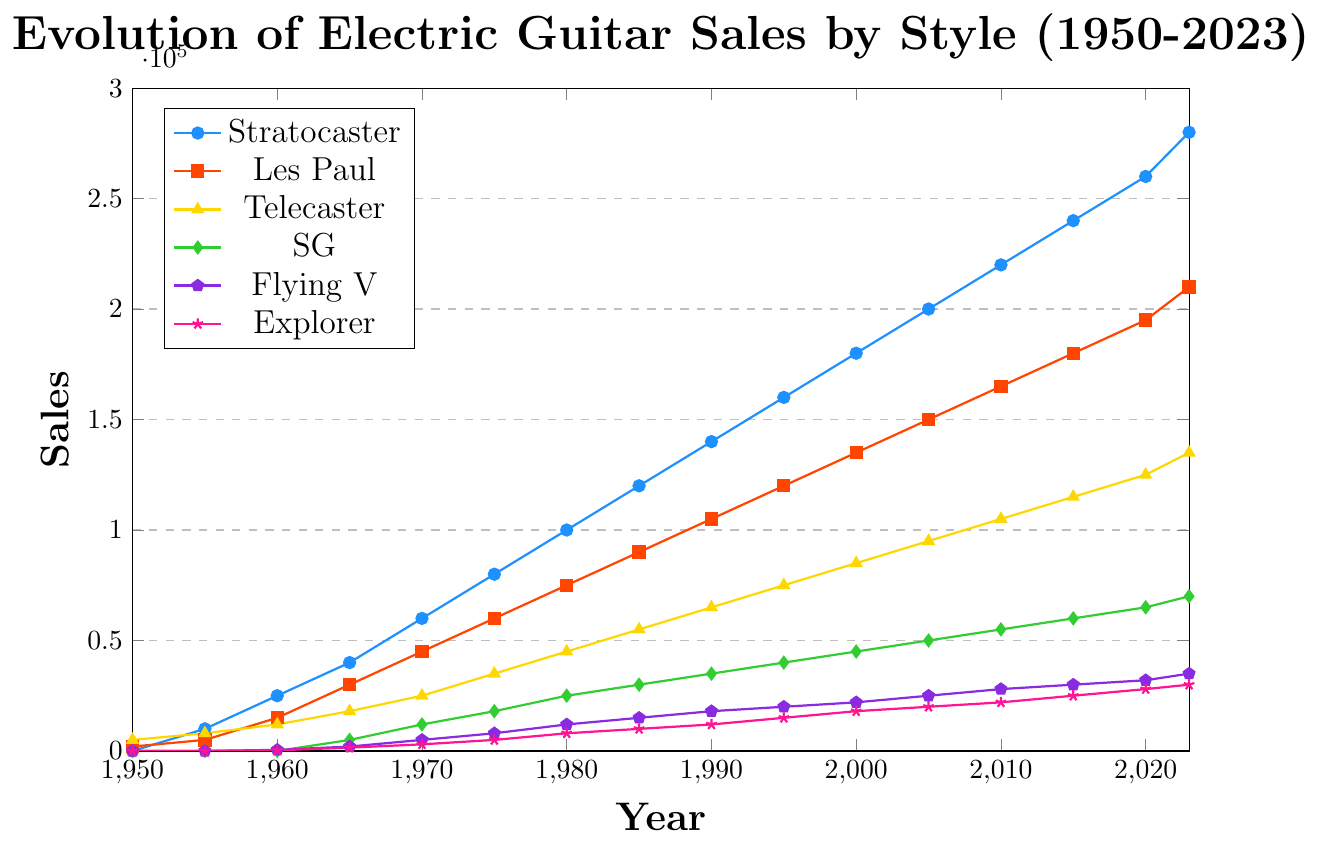Which electric guitar style shows the highest sales in 2023? To find the guitar style with the highest sales in 2023, look at the rightmost data points on the chart. The Stratocaster reaches the highest position on the y-axis, indicating the highest sales.
Answer: Stratocaster How many more Telecasters were sold in 2023 compared to 1950? Locate the sales numbers for Telecasters in 2023 (135,000) and in 1950 (5,000). Subtract the latter from the former: 135,000 - 5,000.
Answer: 130,000 Which electric guitar styles were first sold after 1950? Look for styles that have zero sales in 1950 and non-zero sales in the following years. SG, Flying V, and Explorer start selling after 1950 as they show zero sales initially and some sales later.
Answer: SG, Flying V, Explorer What styles saw a significant sales increase between 1965 and 1970? Identify the styles and their sales in 1965 and 1970. Calculate the differences: Stratocaster (20,000), Les Paul (15,000), SG (7,000). The Stratocaster and Les Paul show the most significant increases.
Answer: Stratocaster, Les Paul Which style experienced the lowest average growth per decade between 1950 and 2020? Calculate the total sales increase for each style over the period, then divide by the number of decades (7). Find the smallest value. E.g., Stratocaster: (260,000 - 0) / 7, Les Paul: (195,000 - 2,000) / 7, SG: (65,000 - 0) / 7, Flying V: (32,000 - 0) / 7, Explorer: (28,000 - 0) / 7, Telecaster: (125,000 - 5,000) / 7. The Explorer has the lowest average growth.
Answer: Explorer Compare the sales trend of the SG and Flying V from 1965 to 2023. Which has the steeper growth rate? Analyze the sales of SG and Flying V in 1965 (SG: 5,000, Flying V: 2,000) and 2023 (SG: 70,000, Flying V: 35,000). Calculate the increase and duration: SG: 70,000 - 5,000 in 58 years, Flying V: 35,000 - 2,000 in 58 years. SG has a higher total increase, indicating a steeper growth rate.
Answer: SG Between Stratocaster and Les Paul, which style had a larger sales increase between 1980 and 2000? Compare Stratocaster's sales increase (180,000 - 100,000) and Les Paul's sales increase (135,000 - 75,000) between 1980 and 2000. Calculate the increases: Stratocaster (80,000), Les Paul (60,000). The Stratocaster had a larger increase.
Answer: Stratocaster What was the sales growth for Explorers from its earliest recorded sales until 2020? Identifying the sales of Explorers at its earliest recorded year (1960: 300) and in 2020 (28,000). Calculate the difference: 28,000 - 300.
Answer: 27,700 How many styles had sales over 100,000 units in 2010? Check the sales for each style in 2010: Stratocaster (220,000), Les Paul (165,000), Telecaster (105,000). Three styles exceeded 100,000.
Answer: 3 styles When did Stratocaster sales first surpass 100,000 units? Observe the sales data for Stratocasters and find the first year where sales exceed 100,000. This occurs in 1980.
Answer: 1980 